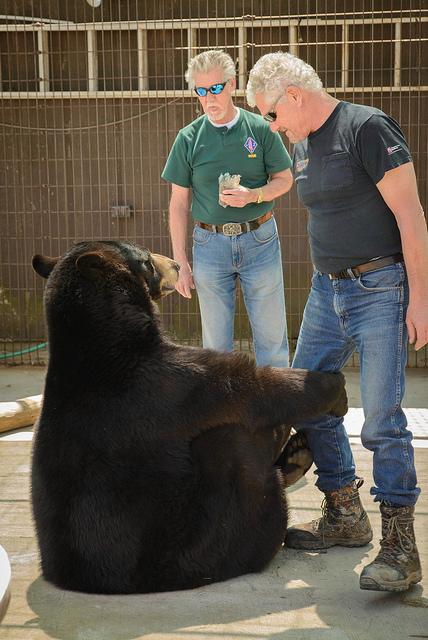Are they wearing goggles?
Give a very brief answer. No. Is the bear sick?
Concise answer only. No. What color are the men's hair?
Answer briefly. Gray. 